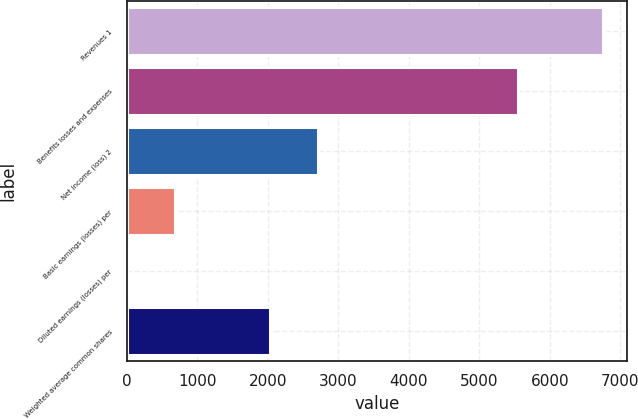<chart> <loc_0><loc_0><loc_500><loc_500><bar_chart><fcel>Revenues 1<fcel>Benefits losses and expenses<fcel>Net income (loss) 2<fcel>Basic earnings (losses) per<fcel>Diluted earnings (losses) per<fcel>Weighted average common shares<nl><fcel>6759<fcel>5547<fcel>2705.23<fcel>678.34<fcel>2.71<fcel>2029.6<nl></chart> 